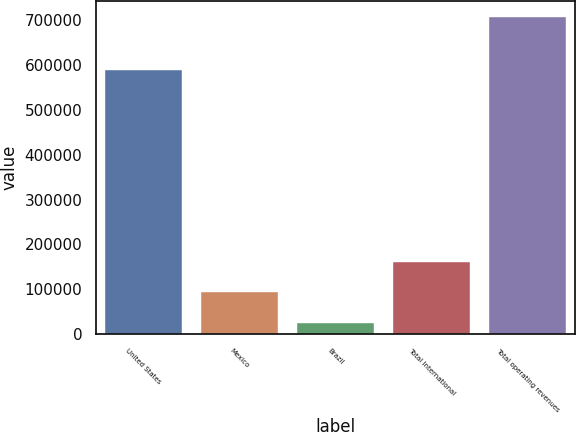Convert chart to OTSL. <chart><loc_0><loc_0><loc_500><loc_500><bar_chart><fcel>United States<fcel>Mexico<fcel>Brazil<fcel>Total International<fcel>Total operating revenues<nl><fcel>589395<fcel>93186<fcel>24079<fcel>161444<fcel>706660<nl></chart> 